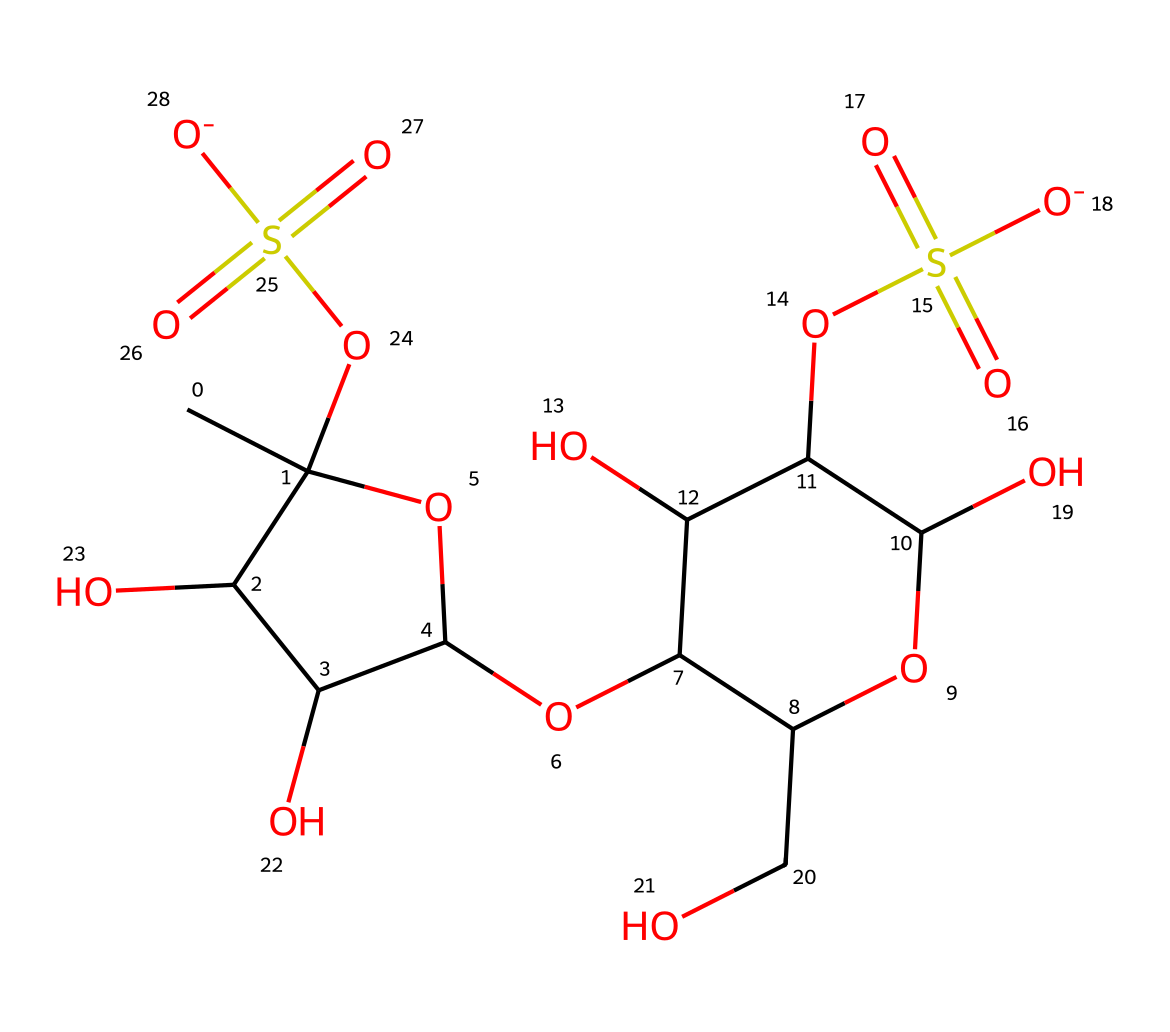What is the overall molecular formula for carrageenan based on the given SMILES? By interpreting the SMILES representation, we can count the number of carbon (C), hydrogen (H), oxygen (O), and sulfur (S) atoms present in the chemical structure. The breakdown yields: C: 12, H: 19, O: 10, S: 2. Therefore, the overall molecular formula is C12H19O10S2.
Answer: C12H19O10S2 How many sulfur atoms are present in carrageenan? The SMILES notation contains the elements 'S', indicating the presence of sulfur. By counting the occurrences, we find there are two sulfur atoms in the structure.
Answer: 2 What type of chemical is carrageenan considered? Carrageenan is a food additive commonly classified as a thickening agent, specifically derived from seaweed. This categorization is due to its application in the food industry primarily for texture modification.
Answer: thickening agent Which functional groups can be identified in this molecular structure? The SMILES reveals multiple functional groups, including hydroxyl (-OH) groups indicated by the letter 'O' in conjunction with carbon atoms, as well as sulfonate (-SO3-) groups represented by 'S(=O)(=O)'.
Answer: hydroxyl, sulfonate What is the significance of the sulfonate groups in carrageenan? The presence of sulfonate groups in carrageenan contributes to its ability to thicken and gel, due to their ionic nature, which affects the interaction with water molecules. This characteristic is vital in forming textured food products, particularly dairy alternatives.
Answer: thickening and gelling property 